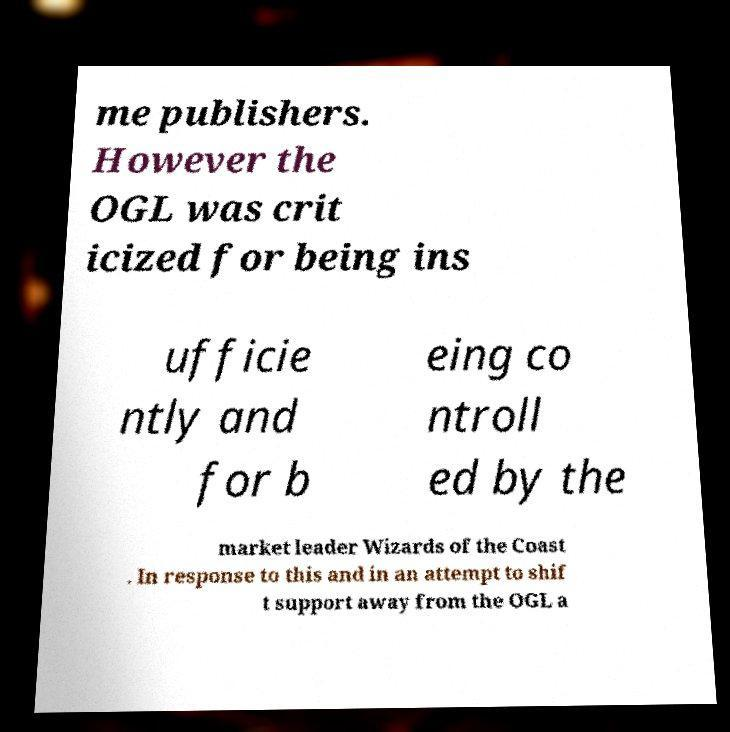Could you assist in decoding the text presented in this image and type it out clearly? me publishers. However the OGL was crit icized for being ins ufficie ntly and for b eing co ntroll ed by the market leader Wizards of the Coast . In response to this and in an attempt to shif t support away from the OGL a 